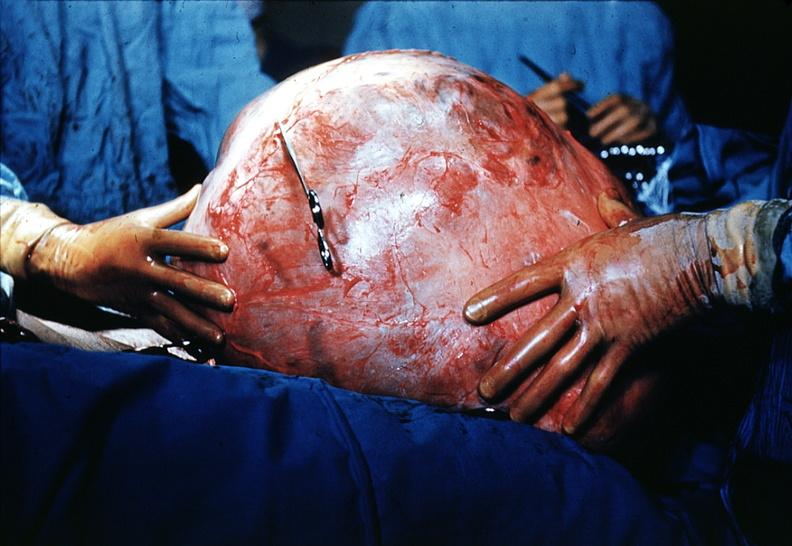does serous cyst show massive lesion taken at surgery size of basketball very good?
Answer the question using a single word or phrase. No 